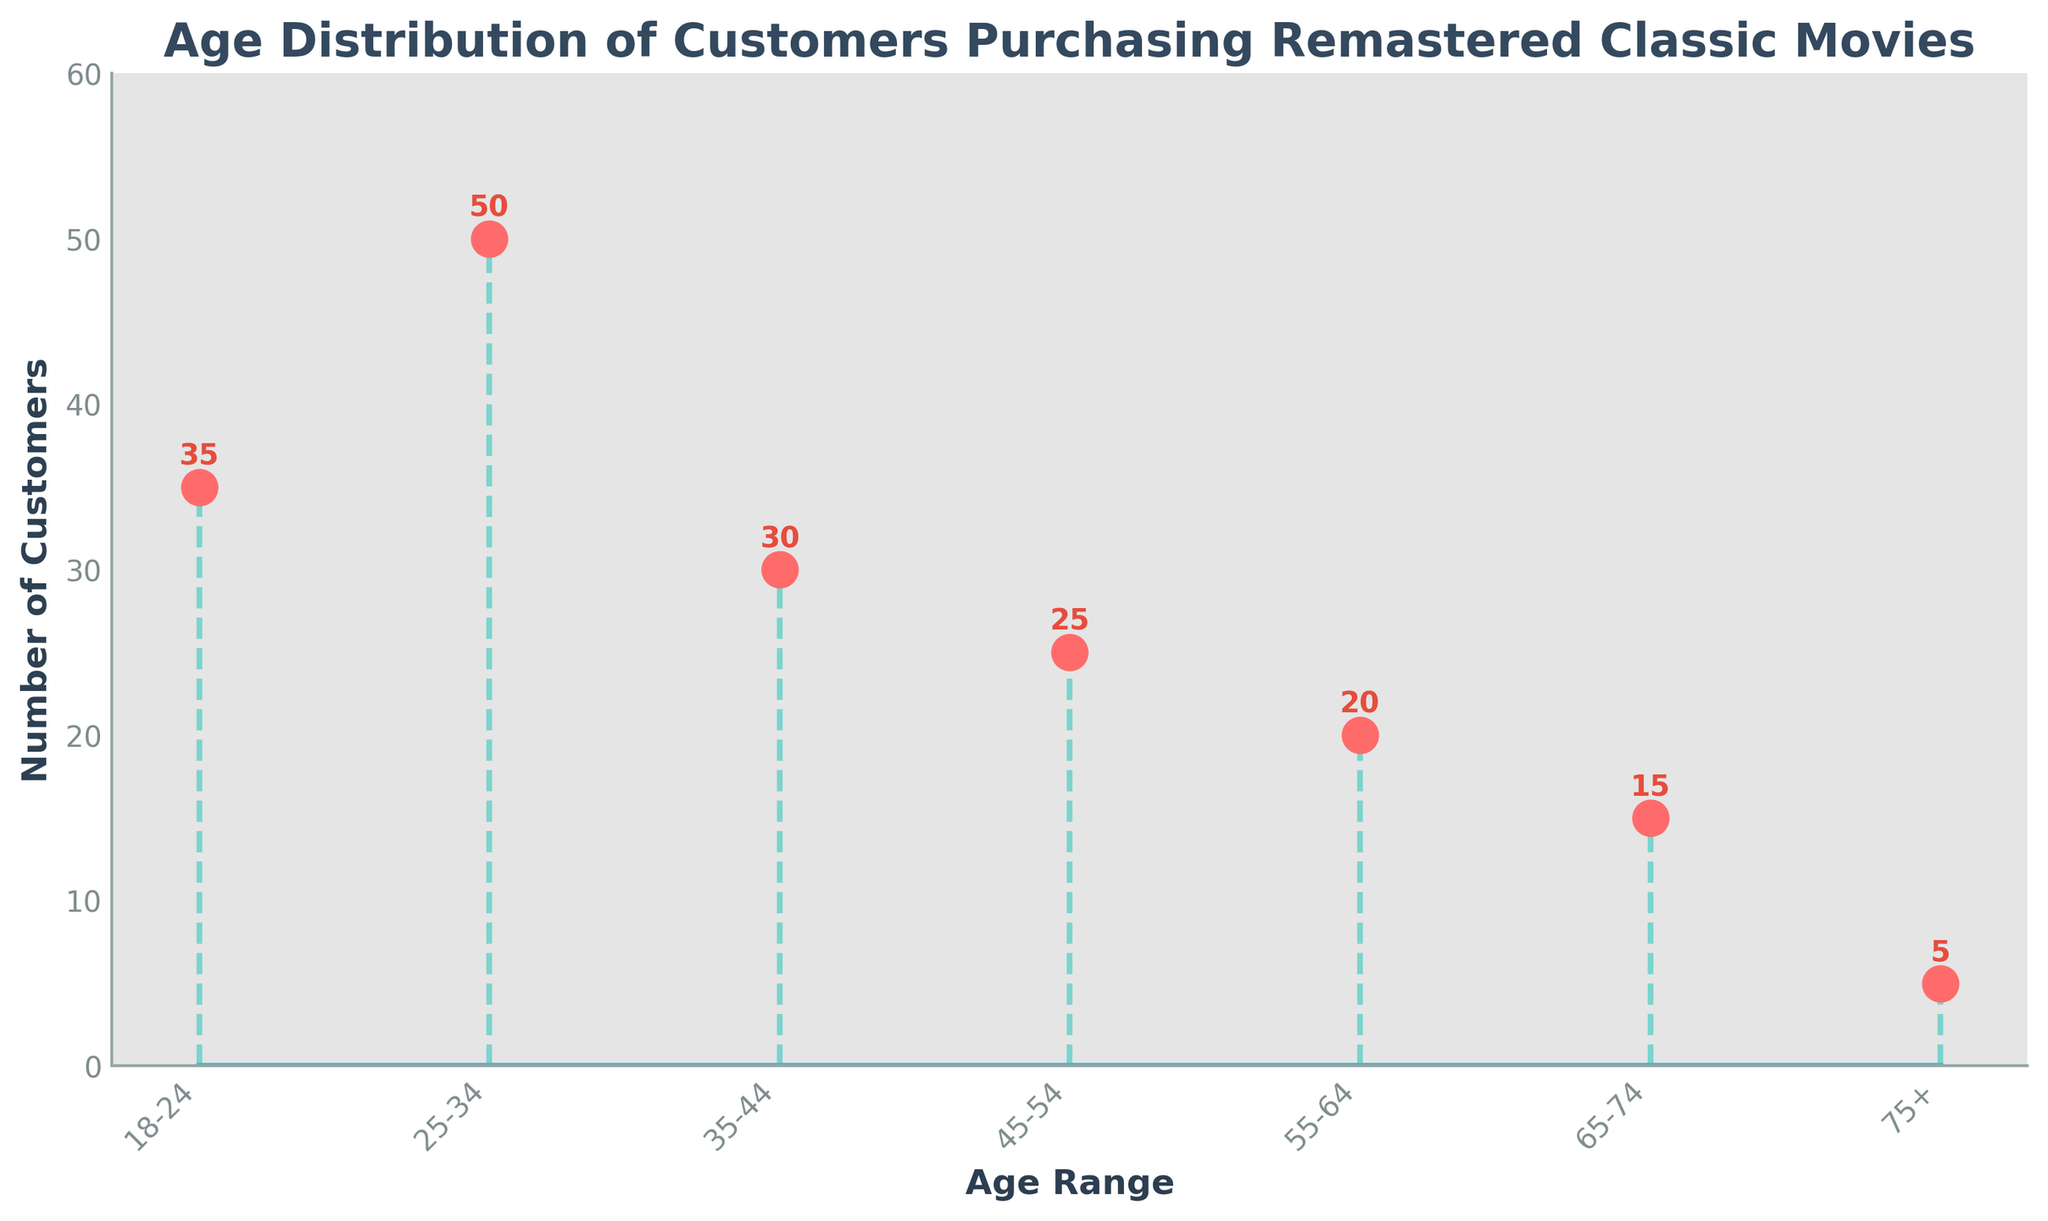What is the title of the figure? The title of the figure is displayed at the top and summarizes the chart's content.
Answer: Age Distribution of Customers Purchasing Remastered Classic Movies How many age ranges are represented in the figure? Count the distinct age ranges displayed on the x-axis.
Answer: Seven Which age range has the highest number of customers? Identify the age range with the tallest stem in the plot.
Answer: 25-34 What is the total number of customers in the 35-44 and 45-54 age ranges combined? Add the counts of customers in the 35-44 and 45-54 age ranges (30 + 25).
Answer: 55 What is the difference in customer count between the 18-24 and 75+ age ranges? Subtract the number of customers in the 75+ age range from the number in the 18-24 age range (35 - 5).
Answer: 30 Which age range has fewer customers: 55-64 or 65-74? Compare the customer counts in the 55-64 and 65-74 age ranges (20 and 15, respectively).
Answer: 65-74 What is the average number of customers across all age ranges? Sum the counts of all age ranges and divide by the number of age ranges ((35 + 50 + 30 + 25 + 20 + 15 + 5) / 7).
Answer: 25 Which age range has the second-highest number of customers? Identify the second tallest stem after the one representing the highest number of customers.
Answer: 18-24 What are the colors used for the marker line and stem lines? Look at the plot's marker line and stem lines, which are visually distinct.
Answer: Red for marker line and green for stem lines What is the total number of customers represented in the figure? Sum the counts of all age ranges in the figure (35 + 50 + 30 + 25 + 20 + 15 + 5).
Answer: 180 